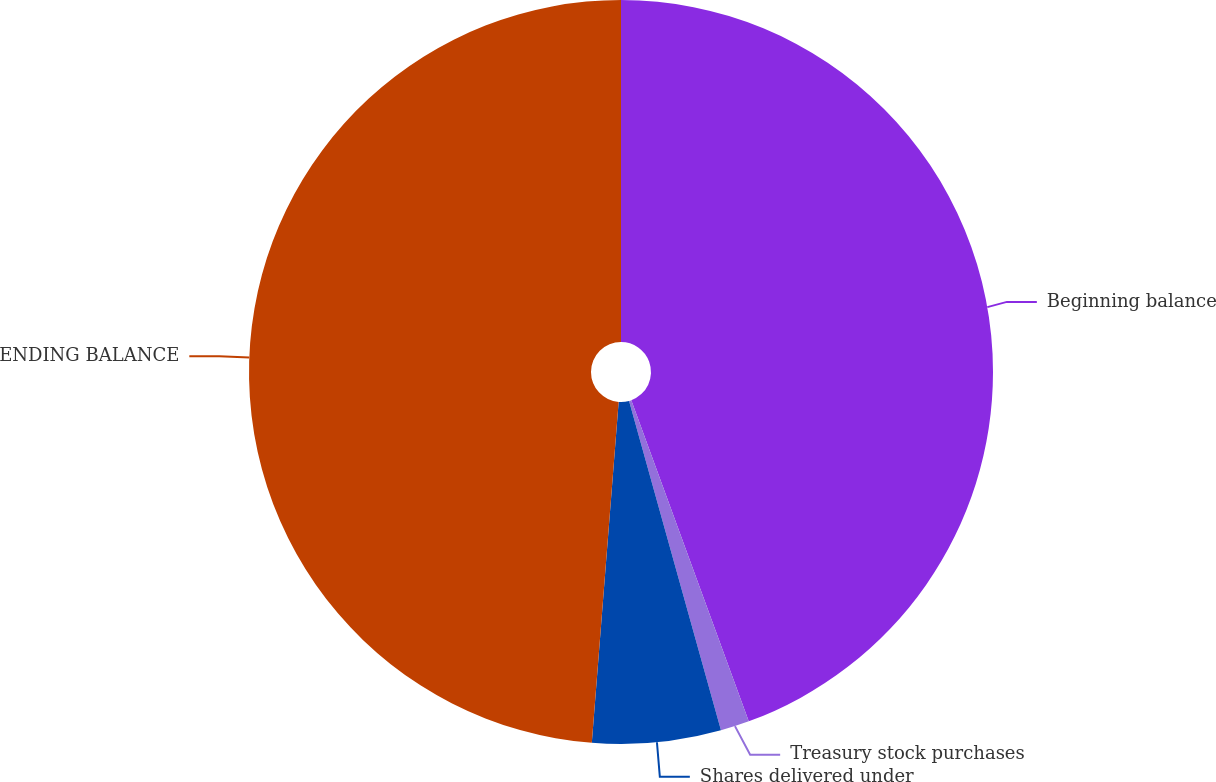Convert chart. <chart><loc_0><loc_0><loc_500><loc_500><pie_chart><fcel>Beginning balance<fcel>Treasury stock purchases<fcel>Shares delivered under<fcel>ENDING BALANCE<nl><fcel>44.42%<fcel>1.25%<fcel>5.58%<fcel>48.75%<nl></chart> 